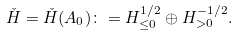<formula> <loc_0><loc_0><loc_500><loc_500>\check { H } = \check { H } ( A _ { 0 } ) \colon = H ^ { 1 / 2 } _ { \leq 0 } \oplus H ^ { - 1 / 2 } _ { > 0 } .</formula> 